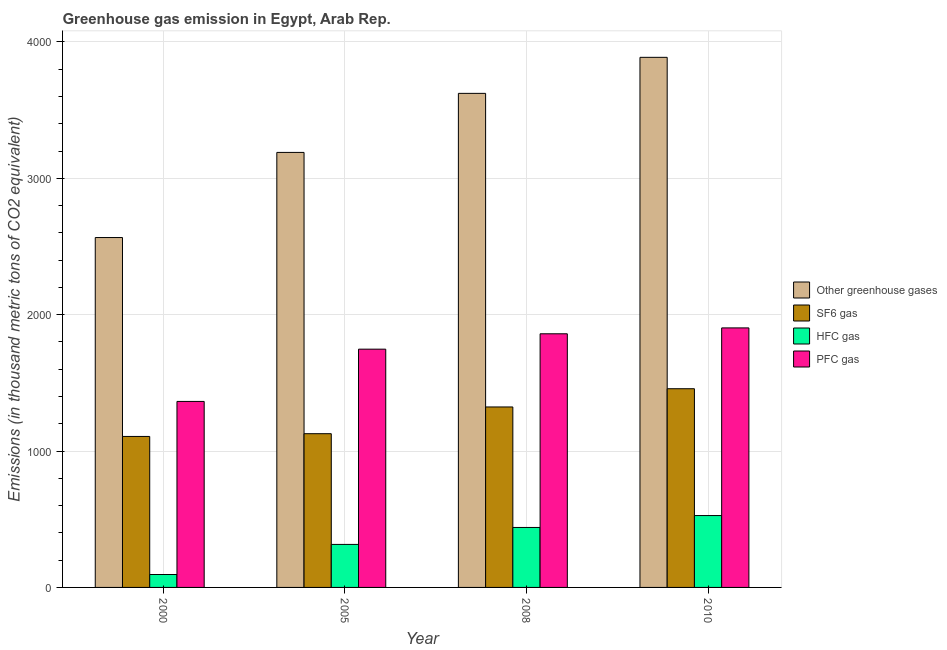How many different coloured bars are there?
Your response must be concise. 4. Are the number of bars per tick equal to the number of legend labels?
Make the answer very short. Yes. How many bars are there on the 4th tick from the left?
Your answer should be very brief. 4. What is the label of the 4th group of bars from the left?
Provide a short and direct response. 2010. In how many cases, is the number of bars for a given year not equal to the number of legend labels?
Your answer should be very brief. 0. What is the emission of pfc gas in 2005?
Keep it short and to the point. 1747.1. Across all years, what is the maximum emission of pfc gas?
Keep it short and to the point. 1903. Across all years, what is the minimum emission of hfc gas?
Provide a succinct answer. 94.7. What is the total emission of hfc gas in the graph?
Give a very brief answer. 1376.8. What is the difference between the emission of hfc gas in 2000 and that in 2010?
Ensure brevity in your answer.  -432.3. What is the difference between the emission of greenhouse gases in 2010 and the emission of sf6 gas in 2000?
Provide a succinct answer. 1321.4. What is the average emission of greenhouse gases per year?
Ensure brevity in your answer.  3316.3. In the year 2010, what is the difference between the emission of greenhouse gases and emission of sf6 gas?
Ensure brevity in your answer.  0. In how many years, is the emission of sf6 gas greater than 1400 thousand metric tons?
Your response must be concise. 1. What is the ratio of the emission of pfc gas in 2000 to that in 2010?
Provide a short and direct response. 0.72. Is the emission of sf6 gas in 2005 less than that in 2008?
Offer a terse response. Yes. Is the difference between the emission of hfc gas in 2005 and 2008 greater than the difference between the emission of sf6 gas in 2005 and 2008?
Keep it short and to the point. No. What is the difference between the highest and the second highest emission of greenhouse gases?
Offer a very short reply. 264.2. What is the difference between the highest and the lowest emission of sf6 gas?
Ensure brevity in your answer.  349.9. In how many years, is the emission of hfc gas greater than the average emission of hfc gas taken over all years?
Give a very brief answer. 2. What does the 4th bar from the left in 2005 represents?
Make the answer very short. PFC gas. What does the 1st bar from the right in 2000 represents?
Give a very brief answer. PFC gas. Is it the case that in every year, the sum of the emission of greenhouse gases and emission of sf6 gas is greater than the emission of hfc gas?
Your answer should be very brief. Yes. How many bars are there?
Make the answer very short. 16. Are all the bars in the graph horizontal?
Your answer should be compact. No. How many years are there in the graph?
Offer a very short reply. 4. Does the graph contain any zero values?
Give a very brief answer. No. Where does the legend appear in the graph?
Your answer should be compact. Center right. What is the title of the graph?
Give a very brief answer. Greenhouse gas emission in Egypt, Arab Rep. What is the label or title of the X-axis?
Offer a terse response. Year. What is the label or title of the Y-axis?
Your response must be concise. Emissions (in thousand metric tons of CO2 equivalent). What is the Emissions (in thousand metric tons of CO2 equivalent) in Other greenhouse gases in 2000?
Your response must be concise. 2565.6. What is the Emissions (in thousand metric tons of CO2 equivalent) in SF6 gas in 2000?
Your response must be concise. 1107.1. What is the Emissions (in thousand metric tons of CO2 equivalent) of HFC gas in 2000?
Offer a very short reply. 94.7. What is the Emissions (in thousand metric tons of CO2 equivalent) in PFC gas in 2000?
Your response must be concise. 1363.8. What is the Emissions (in thousand metric tons of CO2 equivalent) in Other greenhouse gases in 2005?
Ensure brevity in your answer.  3189.8. What is the Emissions (in thousand metric tons of CO2 equivalent) of SF6 gas in 2005?
Provide a short and direct response. 1127.3. What is the Emissions (in thousand metric tons of CO2 equivalent) of HFC gas in 2005?
Make the answer very short. 315.4. What is the Emissions (in thousand metric tons of CO2 equivalent) of PFC gas in 2005?
Your answer should be very brief. 1747.1. What is the Emissions (in thousand metric tons of CO2 equivalent) in Other greenhouse gases in 2008?
Give a very brief answer. 3622.8. What is the Emissions (in thousand metric tons of CO2 equivalent) of SF6 gas in 2008?
Your answer should be compact. 1323.3. What is the Emissions (in thousand metric tons of CO2 equivalent) in HFC gas in 2008?
Give a very brief answer. 439.7. What is the Emissions (in thousand metric tons of CO2 equivalent) in PFC gas in 2008?
Ensure brevity in your answer.  1859.8. What is the Emissions (in thousand metric tons of CO2 equivalent) in Other greenhouse gases in 2010?
Provide a short and direct response. 3887. What is the Emissions (in thousand metric tons of CO2 equivalent) in SF6 gas in 2010?
Your response must be concise. 1457. What is the Emissions (in thousand metric tons of CO2 equivalent) of HFC gas in 2010?
Provide a short and direct response. 527. What is the Emissions (in thousand metric tons of CO2 equivalent) of PFC gas in 2010?
Make the answer very short. 1903. Across all years, what is the maximum Emissions (in thousand metric tons of CO2 equivalent) of Other greenhouse gases?
Your answer should be very brief. 3887. Across all years, what is the maximum Emissions (in thousand metric tons of CO2 equivalent) in SF6 gas?
Your response must be concise. 1457. Across all years, what is the maximum Emissions (in thousand metric tons of CO2 equivalent) of HFC gas?
Give a very brief answer. 527. Across all years, what is the maximum Emissions (in thousand metric tons of CO2 equivalent) of PFC gas?
Your answer should be very brief. 1903. Across all years, what is the minimum Emissions (in thousand metric tons of CO2 equivalent) in Other greenhouse gases?
Give a very brief answer. 2565.6. Across all years, what is the minimum Emissions (in thousand metric tons of CO2 equivalent) in SF6 gas?
Provide a succinct answer. 1107.1. Across all years, what is the minimum Emissions (in thousand metric tons of CO2 equivalent) in HFC gas?
Give a very brief answer. 94.7. Across all years, what is the minimum Emissions (in thousand metric tons of CO2 equivalent) of PFC gas?
Keep it short and to the point. 1363.8. What is the total Emissions (in thousand metric tons of CO2 equivalent) in Other greenhouse gases in the graph?
Provide a short and direct response. 1.33e+04. What is the total Emissions (in thousand metric tons of CO2 equivalent) in SF6 gas in the graph?
Offer a terse response. 5014.7. What is the total Emissions (in thousand metric tons of CO2 equivalent) of HFC gas in the graph?
Make the answer very short. 1376.8. What is the total Emissions (in thousand metric tons of CO2 equivalent) of PFC gas in the graph?
Your answer should be compact. 6873.7. What is the difference between the Emissions (in thousand metric tons of CO2 equivalent) in Other greenhouse gases in 2000 and that in 2005?
Make the answer very short. -624.2. What is the difference between the Emissions (in thousand metric tons of CO2 equivalent) of SF6 gas in 2000 and that in 2005?
Your answer should be compact. -20.2. What is the difference between the Emissions (in thousand metric tons of CO2 equivalent) of HFC gas in 2000 and that in 2005?
Keep it short and to the point. -220.7. What is the difference between the Emissions (in thousand metric tons of CO2 equivalent) of PFC gas in 2000 and that in 2005?
Your response must be concise. -383.3. What is the difference between the Emissions (in thousand metric tons of CO2 equivalent) of Other greenhouse gases in 2000 and that in 2008?
Offer a very short reply. -1057.2. What is the difference between the Emissions (in thousand metric tons of CO2 equivalent) in SF6 gas in 2000 and that in 2008?
Your response must be concise. -216.2. What is the difference between the Emissions (in thousand metric tons of CO2 equivalent) in HFC gas in 2000 and that in 2008?
Provide a succinct answer. -345. What is the difference between the Emissions (in thousand metric tons of CO2 equivalent) in PFC gas in 2000 and that in 2008?
Ensure brevity in your answer.  -496. What is the difference between the Emissions (in thousand metric tons of CO2 equivalent) in Other greenhouse gases in 2000 and that in 2010?
Make the answer very short. -1321.4. What is the difference between the Emissions (in thousand metric tons of CO2 equivalent) in SF6 gas in 2000 and that in 2010?
Ensure brevity in your answer.  -349.9. What is the difference between the Emissions (in thousand metric tons of CO2 equivalent) of HFC gas in 2000 and that in 2010?
Offer a terse response. -432.3. What is the difference between the Emissions (in thousand metric tons of CO2 equivalent) in PFC gas in 2000 and that in 2010?
Provide a succinct answer. -539.2. What is the difference between the Emissions (in thousand metric tons of CO2 equivalent) in Other greenhouse gases in 2005 and that in 2008?
Make the answer very short. -433. What is the difference between the Emissions (in thousand metric tons of CO2 equivalent) of SF6 gas in 2005 and that in 2008?
Ensure brevity in your answer.  -196. What is the difference between the Emissions (in thousand metric tons of CO2 equivalent) of HFC gas in 2005 and that in 2008?
Your response must be concise. -124.3. What is the difference between the Emissions (in thousand metric tons of CO2 equivalent) in PFC gas in 2005 and that in 2008?
Your answer should be very brief. -112.7. What is the difference between the Emissions (in thousand metric tons of CO2 equivalent) in Other greenhouse gases in 2005 and that in 2010?
Your answer should be compact. -697.2. What is the difference between the Emissions (in thousand metric tons of CO2 equivalent) of SF6 gas in 2005 and that in 2010?
Your answer should be compact. -329.7. What is the difference between the Emissions (in thousand metric tons of CO2 equivalent) of HFC gas in 2005 and that in 2010?
Provide a succinct answer. -211.6. What is the difference between the Emissions (in thousand metric tons of CO2 equivalent) in PFC gas in 2005 and that in 2010?
Your response must be concise. -155.9. What is the difference between the Emissions (in thousand metric tons of CO2 equivalent) in Other greenhouse gases in 2008 and that in 2010?
Your response must be concise. -264.2. What is the difference between the Emissions (in thousand metric tons of CO2 equivalent) of SF6 gas in 2008 and that in 2010?
Make the answer very short. -133.7. What is the difference between the Emissions (in thousand metric tons of CO2 equivalent) of HFC gas in 2008 and that in 2010?
Offer a terse response. -87.3. What is the difference between the Emissions (in thousand metric tons of CO2 equivalent) of PFC gas in 2008 and that in 2010?
Keep it short and to the point. -43.2. What is the difference between the Emissions (in thousand metric tons of CO2 equivalent) in Other greenhouse gases in 2000 and the Emissions (in thousand metric tons of CO2 equivalent) in SF6 gas in 2005?
Your answer should be compact. 1438.3. What is the difference between the Emissions (in thousand metric tons of CO2 equivalent) in Other greenhouse gases in 2000 and the Emissions (in thousand metric tons of CO2 equivalent) in HFC gas in 2005?
Provide a short and direct response. 2250.2. What is the difference between the Emissions (in thousand metric tons of CO2 equivalent) of Other greenhouse gases in 2000 and the Emissions (in thousand metric tons of CO2 equivalent) of PFC gas in 2005?
Keep it short and to the point. 818.5. What is the difference between the Emissions (in thousand metric tons of CO2 equivalent) in SF6 gas in 2000 and the Emissions (in thousand metric tons of CO2 equivalent) in HFC gas in 2005?
Provide a short and direct response. 791.7. What is the difference between the Emissions (in thousand metric tons of CO2 equivalent) in SF6 gas in 2000 and the Emissions (in thousand metric tons of CO2 equivalent) in PFC gas in 2005?
Give a very brief answer. -640. What is the difference between the Emissions (in thousand metric tons of CO2 equivalent) in HFC gas in 2000 and the Emissions (in thousand metric tons of CO2 equivalent) in PFC gas in 2005?
Make the answer very short. -1652.4. What is the difference between the Emissions (in thousand metric tons of CO2 equivalent) in Other greenhouse gases in 2000 and the Emissions (in thousand metric tons of CO2 equivalent) in SF6 gas in 2008?
Your response must be concise. 1242.3. What is the difference between the Emissions (in thousand metric tons of CO2 equivalent) of Other greenhouse gases in 2000 and the Emissions (in thousand metric tons of CO2 equivalent) of HFC gas in 2008?
Provide a succinct answer. 2125.9. What is the difference between the Emissions (in thousand metric tons of CO2 equivalent) of Other greenhouse gases in 2000 and the Emissions (in thousand metric tons of CO2 equivalent) of PFC gas in 2008?
Offer a very short reply. 705.8. What is the difference between the Emissions (in thousand metric tons of CO2 equivalent) of SF6 gas in 2000 and the Emissions (in thousand metric tons of CO2 equivalent) of HFC gas in 2008?
Provide a short and direct response. 667.4. What is the difference between the Emissions (in thousand metric tons of CO2 equivalent) in SF6 gas in 2000 and the Emissions (in thousand metric tons of CO2 equivalent) in PFC gas in 2008?
Keep it short and to the point. -752.7. What is the difference between the Emissions (in thousand metric tons of CO2 equivalent) of HFC gas in 2000 and the Emissions (in thousand metric tons of CO2 equivalent) of PFC gas in 2008?
Your answer should be very brief. -1765.1. What is the difference between the Emissions (in thousand metric tons of CO2 equivalent) in Other greenhouse gases in 2000 and the Emissions (in thousand metric tons of CO2 equivalent) in SF6 gas in 2010?
Your answer should be very brief. 1108.6. What is the difference between the Emissions (in thousand metric tons of CO2 equivalent) of Other greenhouse gases in 2000 and the Emissions (in thousand metric tons of CO2 equivalent) of HFC gas in 2010?
Give a very brief answer. 2038.6. What is the difference between the Emissions (in thousand metric tons of CO2 equivalent) in Other greenhouse gases in 2000 and the Emissions (in thousand metric tons of CO2 equivalent) in PFC gas in 2010?
Make the answer very short. 662.6. What is the difference between the Emissions (in thousand metric tons of CO2 equivalent) in SF6 gas in 2000 and the Emissions (in thousand metric tons of CO2 equivalent) in HFC gas in 2010?
Keep it short and to the point. 580.1. What is the difference between the Emissions (in thousand metric tons of CO2 equivalent) of SF6 gas in 2000 and the Emissions (in thousand metric tons of CO2 equivalent) of PFC gas in 2010?
Provide a succinct answer. -795.9. What is the difference between the Emissions (in thousand metric tons of CO2 equivalent) of HFC gas in 2000 and the Emissions (in thousand metric tons of CO2 equivalent) of PFC gas in 2010?
Give a very brief answer. -1808.3. What is the difference between the Emissions (in thousand metric tons of CO2 equivalent) of Other greenhouse gases in 2005 and the Emissions (in thousand metric tons of CO2 equivalent) of SF6 gas in 2008?
Offer a terse response. 1866.5. What is the difference between the Emissions (in thousand metric tons of CO2 equivalent) of Other greenhouse gases in 2005 and the Emissions (in thousand metric tons of CO2 equivalent) of HFC gas in 2008?
Ensure brevity in your answer.  2750.1. What is the difference between the Emissions (in thousand metric tons of CO2 equivalent) of Other greenhouse gases in 2005 and the Emissions (in thousand metric tons of CO2 equivalent) of PFC gas in 2008?
Keep it short and to the point. 1330. What is the difference between the Emissions (in thousand metric tons of CO2 equivalent) in SF6 gas in 2005 and the Emissions (in thousand metric tons of CO2 equivalent) in HFC gas in 2008?
Offer a terse response. 687.6. What is the difference between the Emissions (in thousand metric tons of CO2 equivalent) in SF6 gas in 2005 and the Emissions (in thousand metric tons of CO2 equivalent) in PFC gas in 2008?
Provide a succinct answer. -732.5. What is the difference between the Emissions (in thousand metric tons of CO2 equivalent) of HFC gas in 2005 and the Emissions (in thousand metric tons of CO2 equivalent) of PFC gas in 2008?
Keep it short and to the point. -1544.4. What is the difference between the Emissions (in thousand metric tons of CO2 equivalent) in Other greenhouse gases in 2005 and the Emissions (in thousand metric tons of CO2 equivalent) in SF6 gas in 2010?
Give a very brief answer. 1732.8. What is the difference between the Emissions (in thousand metric tons of CO2 equivalent) of Other greenhouse gases in 2005 and the Emissions (in thousand metric tons of CO2 equivalent) of HFC gas in 2010?
Keep it short and to the point. 2662.8. What is the difference between the Emissions (in thousand metric tons of CO2 equivalent) in Other greenhouse gases in 2005 and the Emissions (in thousand metric tons of CO2 equivalent) in PFC gas in 2010?
Offer a very short reply. 1286.8. What is the difference between the Emissions (in thousand metric tons of CO2 equivalent) in SF6 gas in 2005 and the Emissions (in thousand metric tons of CO2 equivalent) in HFC gas in 2010?
Keep it short and to the point. 600.3. What is the difference between the Emissions (in thousand metric tons of CO2 equivalent) in SF6 gas in 2005 and the Emissions (in thousand metric tons of CO2 equivalent) in PFC gas in 2010?
Offer a terse response. -775.7. What is the difference between the Emissions (in thousand metric tons of CO2 equivalent) of HFC gas in 2005 and the Emissions (in thousand metric tons of CO2 equivalent) of PFC gas in 2010?
Give a very brief answer. -1587.6. What is the difference between the Emissions (in thousand metric tons of CO2 equivalent) in Other greenhouse gases in 2008 and the Emissions (in thousand metric tons of CO2 equivalent) in SF6 gas in 2010?
Ensure brevity in your answer.  2165.8. What is the difference between the Emissions (in thousand metric tons of CO2 equivalent) of Other greenhouse gases in 2008 and the Emissions (in thousand metric tons of CO2 equivalent) of HFC gas in 2010?
Your response must be concise. 3095.8. What is the difference between the Emissions (in thousand metric tons of CO2 equivalent) in Other greenhouse gases in 2008 and the Emissions (in thousand metric tons of CO2 equivalent) in PFC gas in 2010?
Offer a terse response. 1719.8. What is the difference between the Emissions (in thousand metric tons of CO2 equivalent) of SF6 gas in 2008 and the Emissions (in thousand metric tons of CO2 equivalent) of HFC gas in 2010?
Keep it short and to the point. 796.3. What is the difference between the Emissions (in thousand metric tons of CO2 equivalent) of SF6 gas in 2008 and the Emissions (in thousand metric tons of CO2 equivalent) of PFC gas in 2010?
Make the answer very short. -579.7. What is the difference between the Emissions (in thousand metric tons of CO2 equivalent) in HFC gas in 2008 and the Emissions (in thousand metric tons of CO2 equivalent) in PFC gas in 2010?
Give a very brief answer. -1463.3. What is the average Emissions (in thousand metric tons of CO2 equivalent) of Other greenhouse gases per year?
Your response must be concise. 3316.3. What is the average Emissions (in thousand metric tons of CO2 equivalent) of SF6 gas per year?
Offer a very short reply. 1253.67. What is the average Emissions (in thousand metric tons of CO2 equivalent) in HFC gas per year?
Keep it short and to the point. 344.2. What is the average Emissions (in thousand metric tons of CO2 equivalent) in PFC gas per year?
Your answer should be very brief. 1718.42. In the year 2000, what is the difference between the Emissions (in thousand metric tons of CO2 equivalent) in Other greenhouse gases and Emissions (in thousand metric tons of CO2 equivalent) in SF6 gas?
Your answer should be compact. 1458.5. In the year 2000, what is the difference between the Emissions (in thousand metric tons of CO2 equivalent) in Other greenhouse gases and Emissions (in thousand metric tons of CO2 equivalent) in HFC gas?
Your answer should be compact. 2470.9. In the year 2000, what is the difference between the Emissions (in thousand metric tons of CO2 equivalent) of Other greenhouse gases and Emissions (in thousand metric tons of CO2 equivalent) of PFC gas?
Provide a short and direct response. 1201.8. In the year 2000, what is the difference between the Emissions (in thousand metric tons of CO2 equivalent) of SF6 gas and Emissions (in thousand metric tons of CO2 equivalent) of HFC gas?
Give a very brief answer. 1012.4. In the year 2000, what is the difference between the Emissions (in thousand metric tons of CO2 equivalent) in SF6 gas and Emissions (in thousand metric tons of CO2 equivalent) in PFC gas?
Offer a terse response. -256.7. In the year 2000, what is the difference between the Emissions (in thousand metric tons of CO2 equivalent) in HFC gas and Emissions (in thousand metric tons of CO2 equivalent) in PFC gas?
Give a very brief answer. -1269.1. In the year 2005, what is the difference between the Emissions (in thousand metric tons of CO2 equivalent) of Other greenhouse gases and Emissions (in thousand metric tons of CO2 equivalent) of SF6 gas?
Provide a succinct answer. 2062.5. In the year 2005, what is the difference between the Emissions (in thousand metric tons of CO2 equivalent) of Other greenhouse gases and Emissions (in thousand metric tons of CO2 equivalent) of HFC gas?
Give a very brief answer. 2874.4. In the year 2005, what is the difference between the Emissions (in thousand metric tons of CO2 equivalent) in Other greenhouse gases and Emissions (in thousand metric tons of CO2 equivalent) in PFC gas?
Provide a short and direct response. 1442.7. In the year 2005, what is the difference between the Emissions (in thousand metric tons of CO2 equivalent) of SF6 gas and Emissions (in thousand metric tons of CO2 equivalent) of HFC gas?
Give a very brief answer. 811.9. In the year 2005, what is the difference between the Emissions (in thousand metric tons of CO2 equivalent) of SF6 gas and Emissions (in thousand metric tons of CO2 equivalent) of PFC gas?
Your answer should be compact. -619.8. In the year 2005, what is the difference between the Emissions (in thousand metric tons of CO2 equivalent) in HFC gas and Emissions (in thousand metric tons of CO2 equivalent) in PFC gas?
Provide a succinct answer. -1431.7. In the year 2008, what is the difference between the Emissions (in thousand metric tons of CO2 equivalent) in Other greenhouse gases and Emissions (in thousand metric tons of CO2 equivalent) in SF6 gas?
Provide a succinct answer. 2299.5. In the year 2008, what is the difference between the Emissions (in thousand metric tons of CO2 equivalent) in Other greenhouse gases and Emissions (in thousand metric tons of CO2 equivalent) in HFC gas?
Give a very brief answer. 3183.1. In the year 2008, what is the difference between the Emissions (in thousand metric tons of CO2 equivalent) of Other greenhouse gases and Emissions (in thousand metric tons of CO2 equivalent) of PFC gas?
Your response must be concise. 1763. In the year 2008, what is the difference between the Emissions (in thousand metric tons of CO2 equivalent) in SF6 gas and Emissions (in thousand metric tons of CO2 equivalent) in HFC gas?
Provide a short and direct response. 883.6. In the year 2008, what is the difference between the Emissions (in thousand metric tons of CO2 equivalent) of SF6 gas and Emissions (in thousand metric tons of CO2 equivalent) of PFC gas?
Keep it short and to the point. -536.5. In the year 2008, what is the difference between the Emissions (in thousand metric tons of CO2 equivalent) in HFC gas and Emissions (in thousand metric tons of CO2 equivalent) in PFC gas?
Provide a succinct answer. -1420.1. In the year 2010, what is the difference between the Emissions (in thousand metric tons of CO2 equivalent) in Other greenhouse gases and Emissions (in thousand metric tons of CO2 equivalent) in SF6 gas?
Your answer should be compact. 2430. In the year 2010, what is the difference between the Emissions (in thousand metric tons of CO2 equivalent) of Other greenhouse gases and Emissions (in thousand metric tons of CO2 equivalent) of HFC gas?
Make the answer very short. 3360. In the year 2010, what is the difference between the Emissions (in thousand metric tons of CO2 equivalent) in Other greenhouse gases and Emissions (in thousand metric tons of CO2 equivalent) in PFC gas?
Offer a very short reply. 1984. In the year 2010, what is the difference between the Emissions (in thousand metric tons of CO2 equivalent) of SF6 gas and Emissions (in thousand metric tons of CO2 equivalent) of HFC gas?
Your response must be concise. 930. In the year 2010, what is the difference between the Emissions (in thousand metric tons of CO2 equivalent) in SF6 gas and Emissions (in thousand metric tons of CO2 equivalent) in PFC gas?
Your answer should be very brief. -446. In the year 2010, what is the difference between the Emissions (in thousand metric tons of CO2 equivalent) of HFC gas and Emissions (in thousand metric tons of CO2 equivalent) of PFC gas?
Give a very brief answer. -1376. What is the ratio of the Emissions (in thousand metric tons of CO2 equivalent) in Other greenhouse gases in 2000 to that in 2005?
Offer a terse response. 0.8. What is the ratio of the Emissions (in thousand metric tons of CO2 equivalent) in SF6 gas in 2000 to that in 2005?
Your response must be concise. 0.98. What is the ratio of the Emissions (in thousand metric tons of CO2 equivalent) in HFC gas in 2000 to that in 2005?
Make the answer very short. 0.3. What is the ratio of the Emissions (in thousand metric tons of CO2 equivalent) of PFC gas in 2000 to that in 2005?
Give a very brief answer. 0.78. What is the ratio of the Emissions (in thousand metric tons of CO2 equivalent) in Other greenhouse gases in 2000 to that in 2008?
Offer a very short reply. 0.71. What is the ratio of the Emissions (in thousand metric tons of CO2 equivalent) of SF6 gas in 2000 to that in 2008?
Provide a short and direct response. 0.84. What is the ratio of the Emissions (in thousand metric tons of CO2 equivalent) of HFC gas in 2000 to that in 2008?
Ensure brevity in your answer.  0.22. What is the ratio of the Emissions (in thousand metric tons of CO2 equivalent) of PFC gas in 2000 to that in 2008?
Make the answer very short. 0.73. What is the ratio of the Emissions (in thousand metric tons of CO2 equivalent) in Other greenhouse gases in 2000 to that in 2010?
Offer a very short reply. 0.66. What is the ratio of the Emissions (in thousand metric tons of CO2 equivalent) in SF6 gas in 2000 to that in 2010?
Make the answer very short. 0.76. What is the ratio of the Emissions (in thousand metric tons of CO2 equivalent) in HFC gas in 2000 to that in 2010?
Give a very brief answer. 0.18. What is the ratio of the Emissions (in thousand metric tons of CO2 equivalent) of PFC gas in 2000 to that in 2010?
Your answer should be compact. 0.72. What is the ratio of the Emissions (in thousand metric tons of CO2 equivalent) in Other greenhouse gases in 2005 to that in 2008?
Your answer should be very brief. 0.88. What is the ratio of the Emissions (in thousand metric tons of CO2 equivalent) of SF6 gas in 2005 to that in 2008?
Your answer should be very brief. 0.85. What is the ratio of the Emissions (in thousand metric tons of CO2 equivalent) in HFC gas in 2005 to that in 2008?
Offer a very short reply. 0.72. What is the ratio of the Emissions (in thousand metric tons of CO2 equivalent) of PFC gas in 2005 to that in 2008?
Ensure brevity in your answer.  0.94. What is the ratio of the Emissions (in thousand metric tons of CO2 equivalent) of Other greenhouse gases in 2005 to that in 2010?
Make the answer very short. 0.82. What is the ratio of the Emissions (in thousand metric tons of CO2 equivalent) in SF6 gas in 2005 to that in 2010?
Ensure brevity in your answer.  0.77. What is the ratio of the Emissions (in thousand metric tons of CO2 equivalent) of HFC gas in 2005 to that in 2010?
Your answer should be very brief. 0.6. What is the ratio of the Emissions (in thousand metric tons of CO2 equivalent) of PFC gas in 2005 to that in 2010?
Give a very brief answer. 0.92. What is the ratio of the Emissions (in thousand metric tons of CO2 equivalent) in Other greenhouse gases in 2008 to that in 2010?
Offer a terse response. 0.93. What is the ratio of the Emissions (in thousand metric tons of CO2 equivalent) in SF6 gas in 2008 to that in 2010?
Provide a succinct answer. 0.91. What is the ratio of the Emissions (in thousand metric tons of CO2 equivalent) of HFC gas in 2008 to that in 2010?
Your response must be concise. 0.83. What is the ratio of the Emissions (in thousand metric tons of CO2 equivalent) of PFC gas in 2008 to that in 2010?
Give a very brief answer. 0.98. What is the difference between the highest and the second highest Emissions (in thousand metric tons of CO2 equivalent) in Other greenhouse gases?
Offer a terse response. 264.2. What is the difference between the highest and the second highest Emissions (in thousand metric tons of CO2 equivalent) in SF6 gas?
Keep it short and to the point. 133.7. What is the difference between the highest and the second highest Emissions (in thousand metric tons of CO2 equivalent) in HFC gas?
Your answer should be very brief. 87.3. What is the difference between the highest and the second highest Emissions (in thousand metric tons of CO2 equivalent) in PFC gas?
Offer a terse response. 43.2. What is the difference between the highest and the lowest Emissions (in thousand metric tons of CO2 equivalent) of Other greenhouse gases?
Your answer should be compact. 1321.4. What is the difference between the highest and the lowest Emissions (in thousand metric tons of CO2 equivalent) of SF6 gas?
Your answer should be compact. 349.9. What is the difference between the highest and the lowest Emissions (in thousand metric tons of CO2 equivalent) of HFC gas?
Your response must be concise. 432.3. What is the difference between the highest and the lowest Emissions (in thousand metric tons of CO2 equivalent) in PFC gas?
Keep it short and to the point. 539.2. 